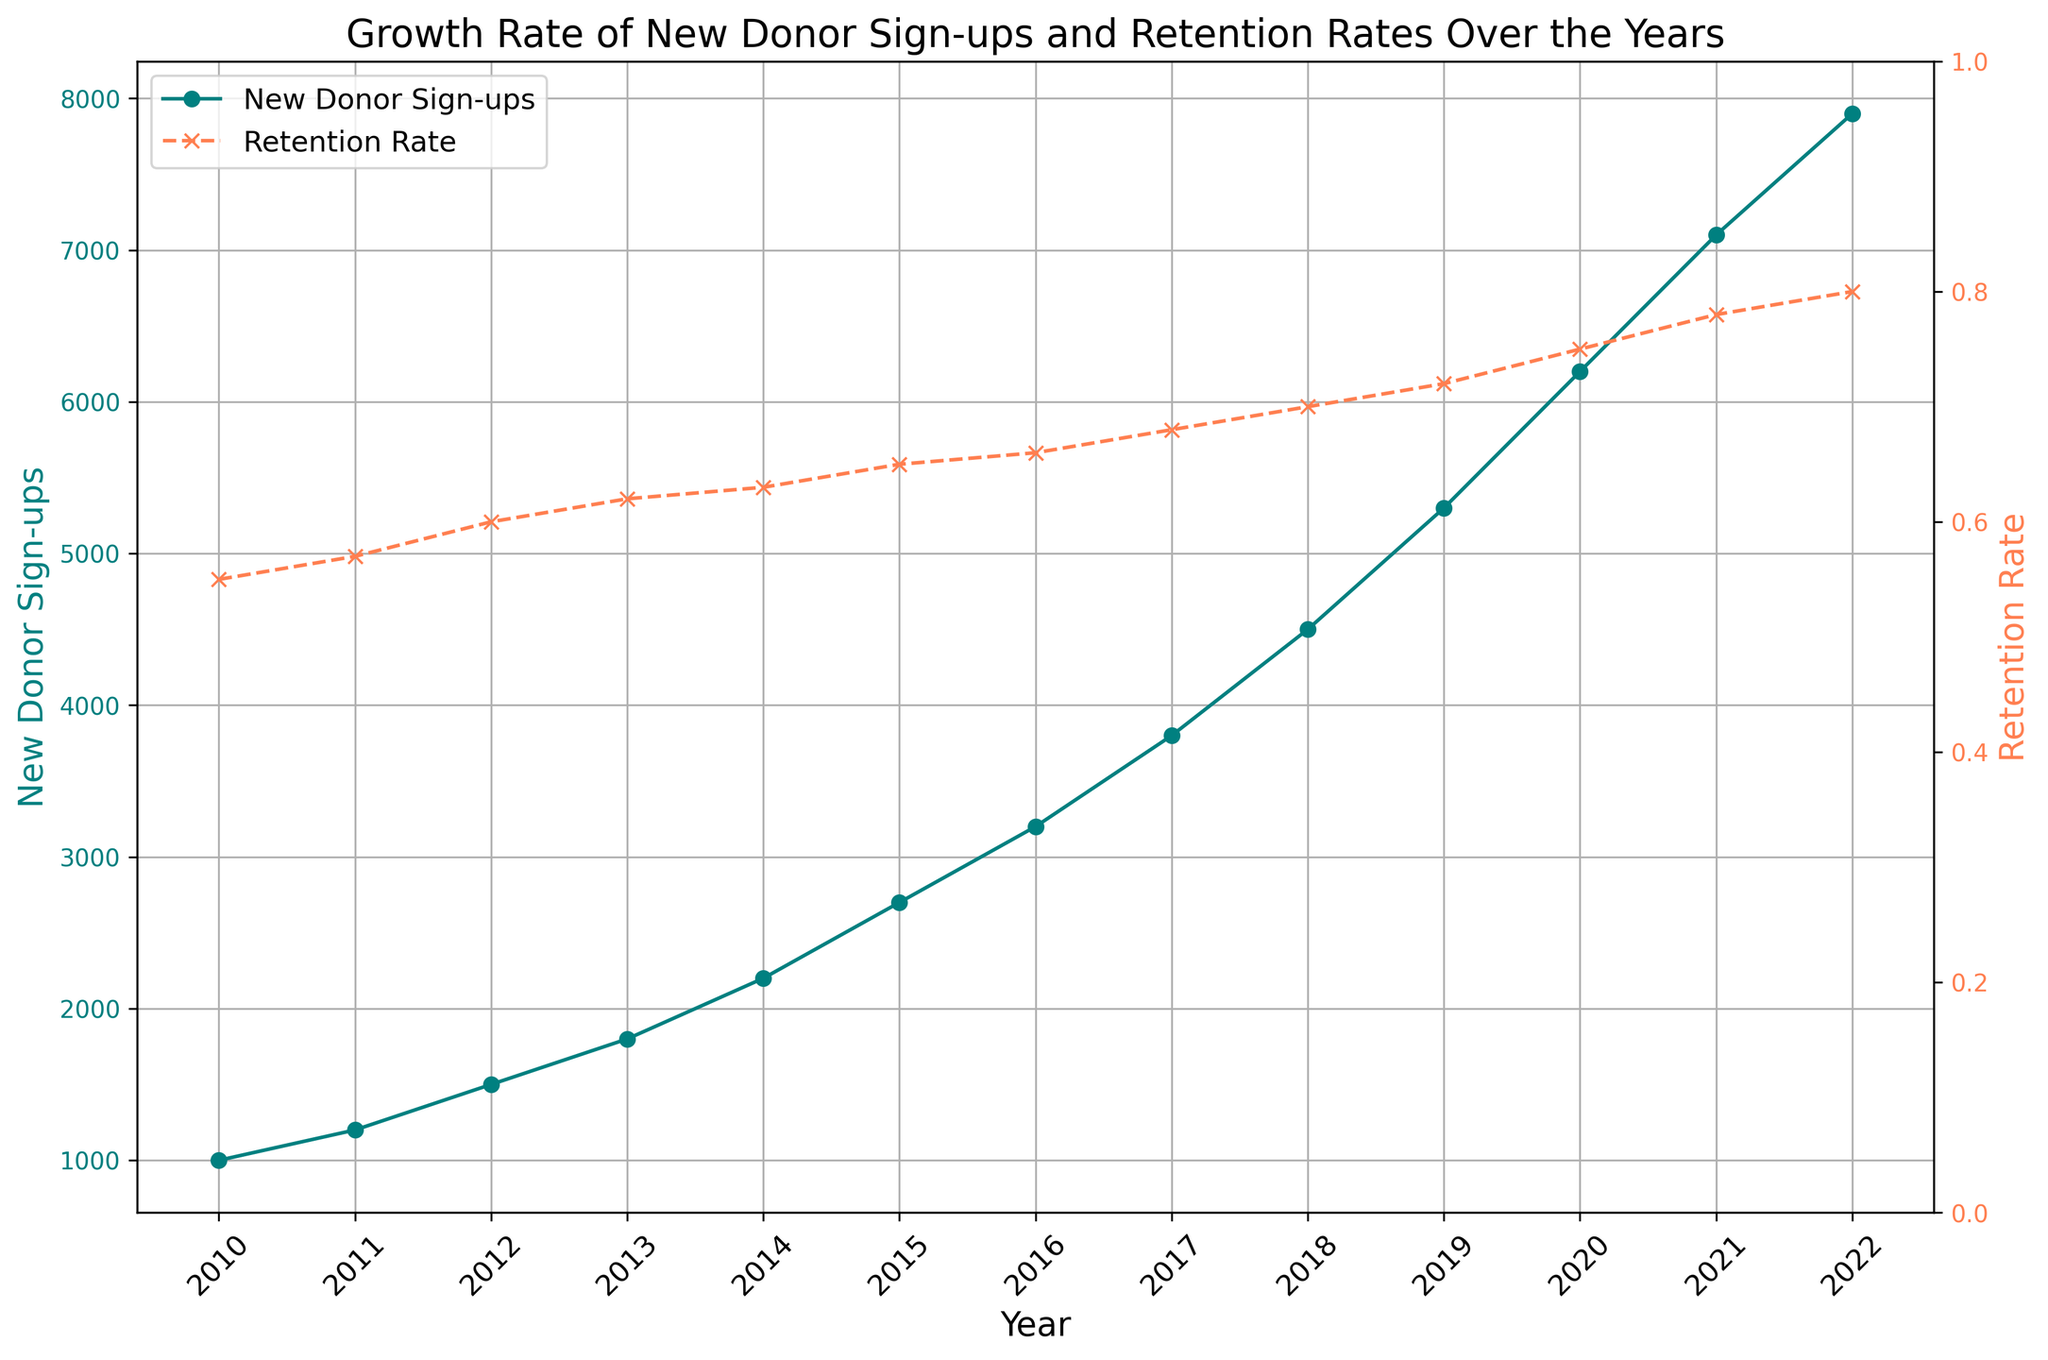What's the highest retention rate observed in the plot? The highest retention rate can be identified by looking for the highest point on the coral line representing the retention rate. According to the plot, the highest retention rate is at the year 2022. Check the y-axis value corresponding to this point.
Answer: 0.80 How many new donor sign-ups occurred in 2015? To find the new donor sign-ups in 2015, look at the year 2015 on the x-axis and find the corresponding y-axis value on the teal line representing new donor sign-ups.
Answer: 2700 What is the percentage increase in new donor sign-ups from 2010 to 2022? Calculate the percentage increase by deducting the number of new donor sign-ups in 2010 from that in 2022, divide by the number in 2010, and multiply by 100. ((7900 - 1000) / 1000) * 100 = 690%
Answer: 690% What is the average retention rate from 2010 to 2022? Sum all the retention rates from 2010 to 2022 and divide by the number of years (13). (0.55 + 0.57 + 0.60 + 0.62 + 0.63 + 0.65 + 0.66 + 0.68 + 0.70 + 0.72 + 0.75 + 0.78 + 0.80) / 13 ≈ 0.676
Answer: 0.676 Between which two consecutive years was the highest increase in new donor sign-ups observed? Identify the largest difference between consecutive years by subtracting each year's new donor sign-up count from the next year's count. The largest difference is between 2021 and 2022 (7900 - 7100 = 800).
Answer: 2021 and 2022 In which year did the retention rate first reach 0.70? Find the year on the x-axis where the coral line's retention rate first crosses the 0.70 mark on the y-axis. This occurs in the year 2018.
Answer: 2018 What is the difference in retention rates between 2010 and 2022? Subtract the retention rate in 2010 (0.55) from the retention rate in 2022 (0.80). 0.80 - 0.55 = 0.25
Answer: 0.25 By how much did new donor sign-ups increase from 2011 to 2014? Subtract the number of new donor sign-ups in 2011 from that in 2014. 2200 - 1200 = 1000
Answer: 1000 Which year had a retention rate closest to 0.60? Find the year on the x-axis where the retention rate line is closest to the 0.60 mark. This occurs in the year 2012.
Answer: 2012 